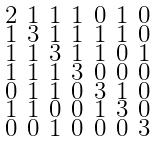<formula> <loc_0><loc_0><loc_500><loc_500>\begin{smallmatrix} 2 & 1 & 1 & 1 & 0 & 1 & 0 \\ 1 & 3 & 1 & 1 & 1 & 1 & 0 \\ 1 & 1 & 3 & 1 & 1 & 0 & 1 \\ 1 & 1 & 1 & 3 & 0 & 0 & 0 \\ 0 & 1 & 1 & 0 & 3 & 1 & 0 \\ 1 & 1 & 0 & 0 & 1 & 3 & 0 \\ 0 & 0 & 1 & 0 & 0 & 0 & 3 \end{smallmatrix}</formula> 